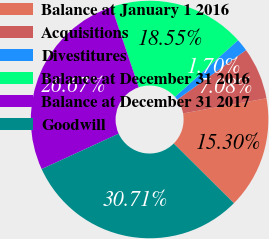<chart> <loc_0><loc_0><loc_500><loc_500><pie_chart><fcel>Balance at January 1 2016<fcel>Acquisitions<fcel>Divestitures<fcel>Balance at December 31 2016<fcel>Balance at December 31 2017<fcel>Goodwill<nl><fcel>15.3%<fcel>7.08%<fcel>1.7%<fcel>18.55%<fcel>26.67%<fcel>30.71%<nl></chart> 